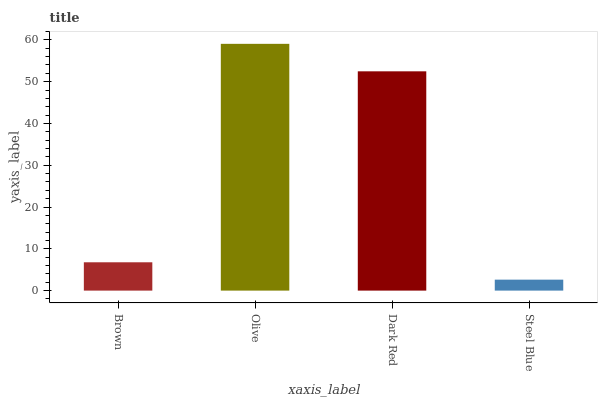Is Steel Blue the minimum?
Answer yes or no. Yes. Is Olive the maximum?
Answer yes or no. Yes. Is Dark Red the minimum?
Answer yes or no. No. Is Dark Red the maximum?
Answer yes or no. No. Is Olive greater than Dark Red?
Answer yes or no. Yes. Is Dark Red less than Olive?
Answer yes or no. Yes. Is Dark Red greater than Olive?
Answer yes or no. No. Is Olive less than Dark Red?
Answer yes or no. No. Is Dark Red the high median?
Answer yes or no. Yes. Is Brown the low median?
Answer yes or no. Yes. Is Olive the high median?
Answer yes or no. No. Is Steel Blue the low median?
Answer yes or no. No. 